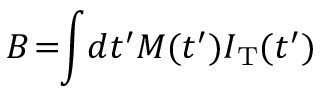Convert formula to latex. <formula><loc_0><loc_0><loc_500><loc_500>B \, = \, \int \, d t ^ { \prime } M ( t ^ { \prime } ) I _ { T } ( t ^ { \prime } )</formula> 